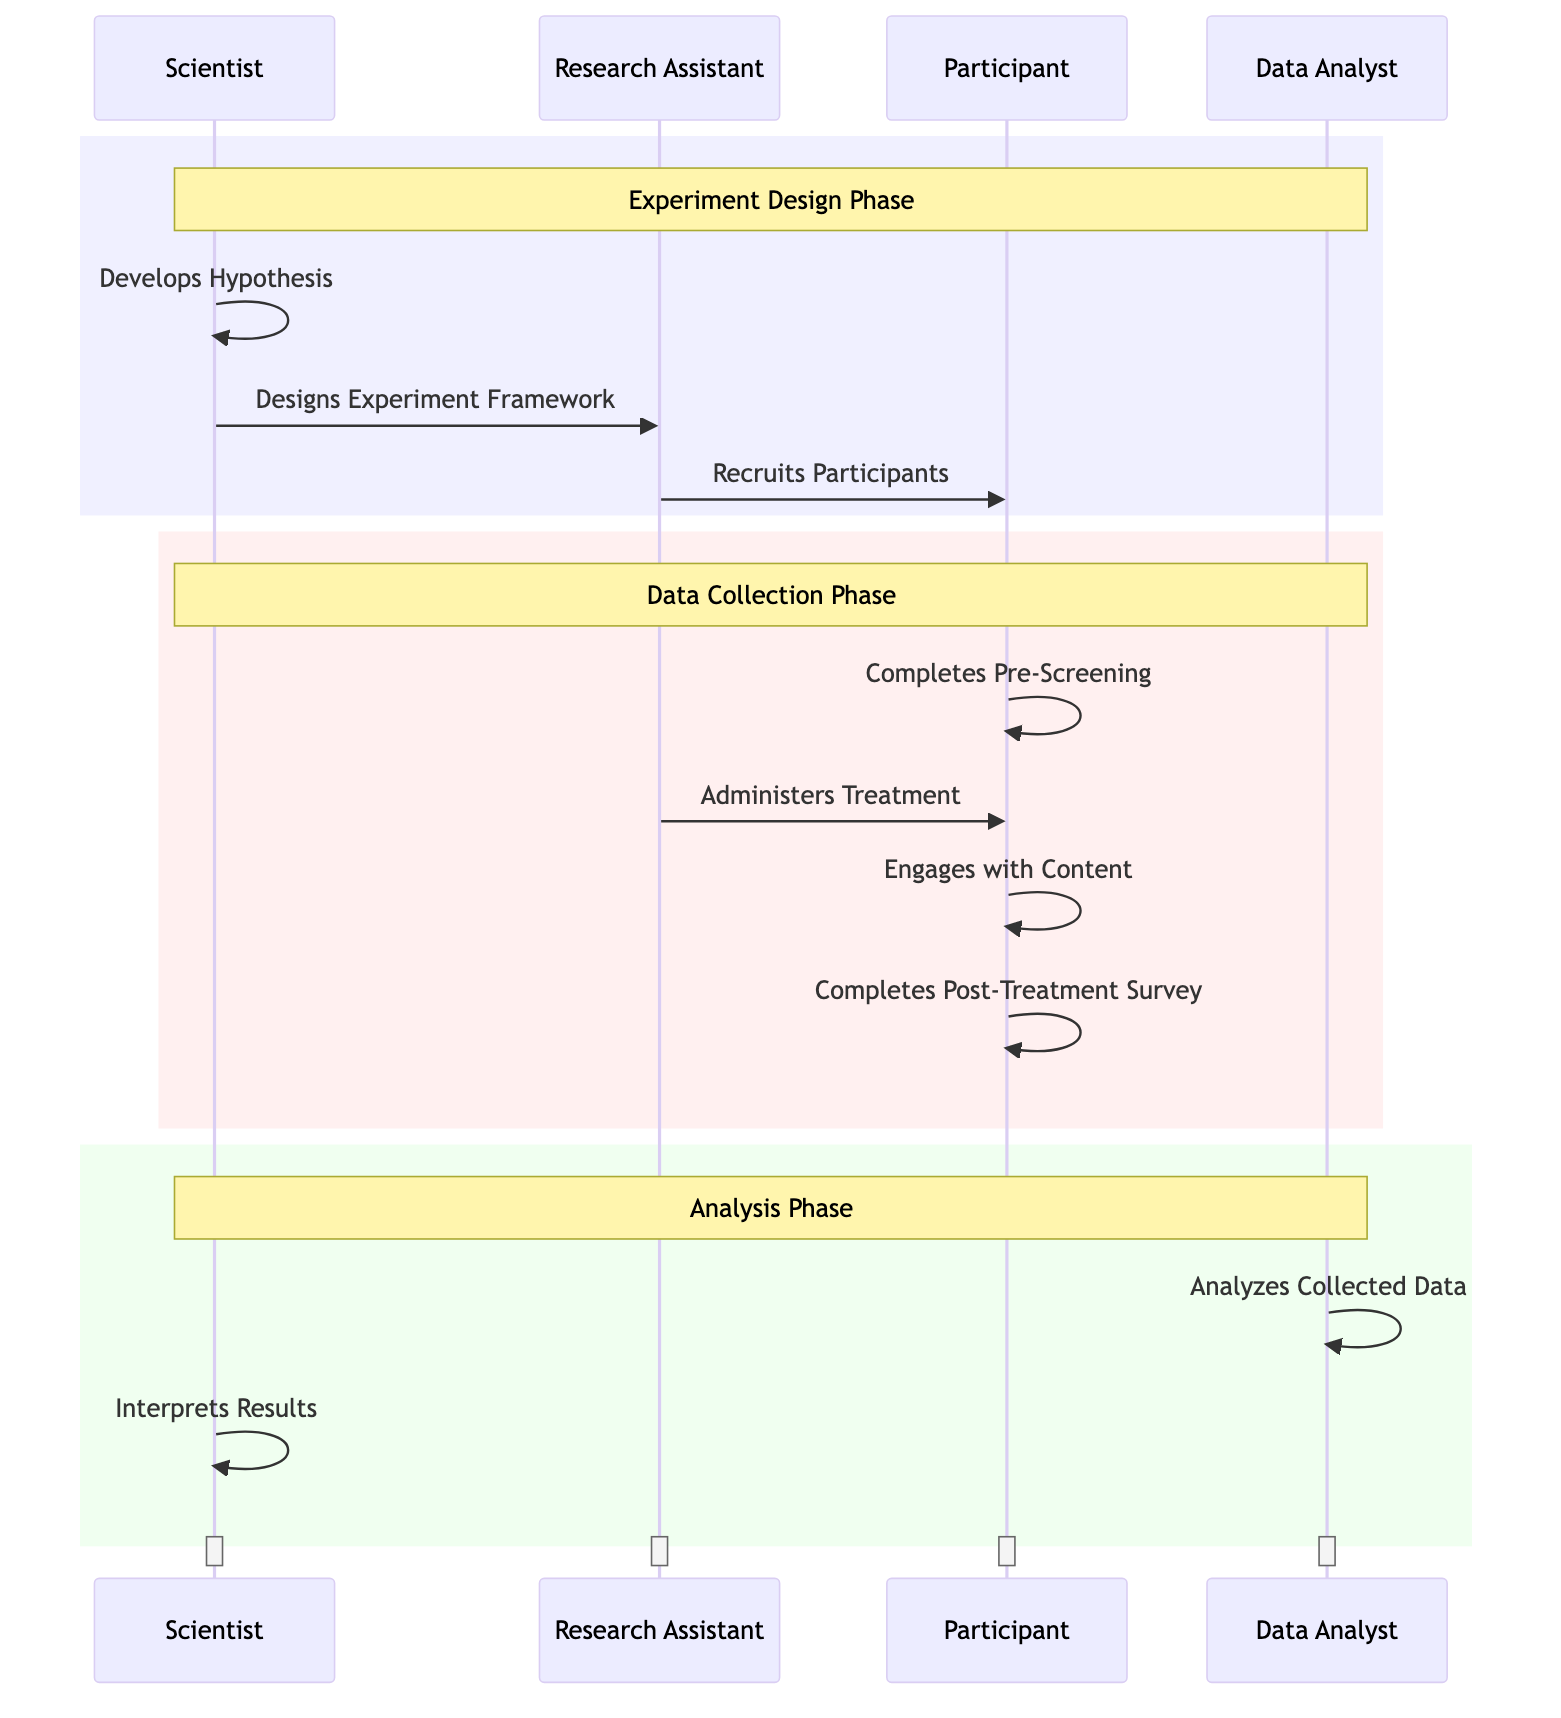What is the first action taken by the Scientist? The first action taken by the Scientist is "Develops Hypothesis," as indicated in the diagram where the Scientist initiates the experiment design phase.
Answer: Develops Hypothesis How many participants are involved in the recruiting process? The diagram depicts a single action where the Research Assistant recruits unspecified participants, indicating involvement of multiple participants but does not specify the number.
Answer: Multiple Who administers the treatment in the experiment? The diagram clearly shows that the Research Assistant is responsible for administering treatment to the participants, making them the key actor for this action.
Answer: Research Assistant What is the phase called where data is analyzed? The phase where data is analyzed is labeled as the "Analysis Phase" in the diagram. This distinguishes it from the other phases of experiment design and data collection.
Answer: Analysis Phase What action does the Participant take after engaging with the content? After engaging with the content, the Participant completes the post-treatment survey, as indicated in the sequence of actions shown in the diagram.
Answer: Completes Post-Treatment Survey Which actor is involved in both developing the hypothesis and interpreting the results? The Scientist is involved in both developing the hypothesis and interpreting the results, as evidenced by the actions attributed to the Scientist in the two distinct phases of the experiment.
Answer: Scientist How many distinct phases are identified in the diagram? There are three distinct phases identified: Experiment Design Phase, Data Collection Phase, and Analysis Phase, which are clearly demarcated by different backgrounds in the diagram.
Answer: Three In what order do the actions related to the Participant occur? The order of actions related to the Participant is as follows: Completes Pre-Screening, Engages with Content, Completes Post-Treatment Survey, sequentially demonstrating the flow of participation.
Answer: Pre-Screening, Engages with Content, Post-Treatment Survey What is the role of the Data Analyst in this sequence? The role of the Data Analyst in this sequence is to analyze collected data after the data collection phase, which occurs in the later part of the sequence diagram.
Answer: Analyzes Collected Data 